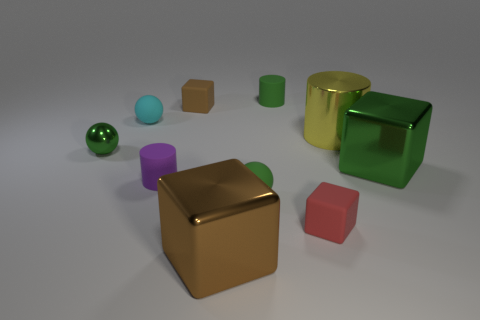What material is the small green thing that is to the left of the tiny cylinder that is to the left of the tiny brown rubber thing?
Offer a very short reply. Metal. The purple matte thing is what size?
Offer a very short reply. Small. What is the size of the purple object that is the same material as the small red cube?
Offer a very short reply. Small. There is a matte cube to the right of the brown shiny block; is it the same size as the green cube?
Your response must be concise. No. There is a green rubber thing to the right of the green thing that is in front of the large metallic cube to the right of the brown shiny cube; what is its shape?
Your answer should be very brief. Cylinder. How many things are red matte things or small matte cubes that are to the right of the small purple rubber cylinder?
Provide a succinct answer. 2. What size is the green cylinder behind the brown rubber cube?
Ensure brevity in your answer.  Small. Is the large brown object made of the same material as the tiny cylinder that is to the right of the purple rubber cylinder?
Provide a short and direct response. No. There is a green metallic object on the left side of the brown cube that is in front of the red object; how many large brown things are on the right side of it?
Give a very brief answer. 1. What number of blue things are either big metal things or rubber blocks?
Ensure brevity in your answer.  0. 